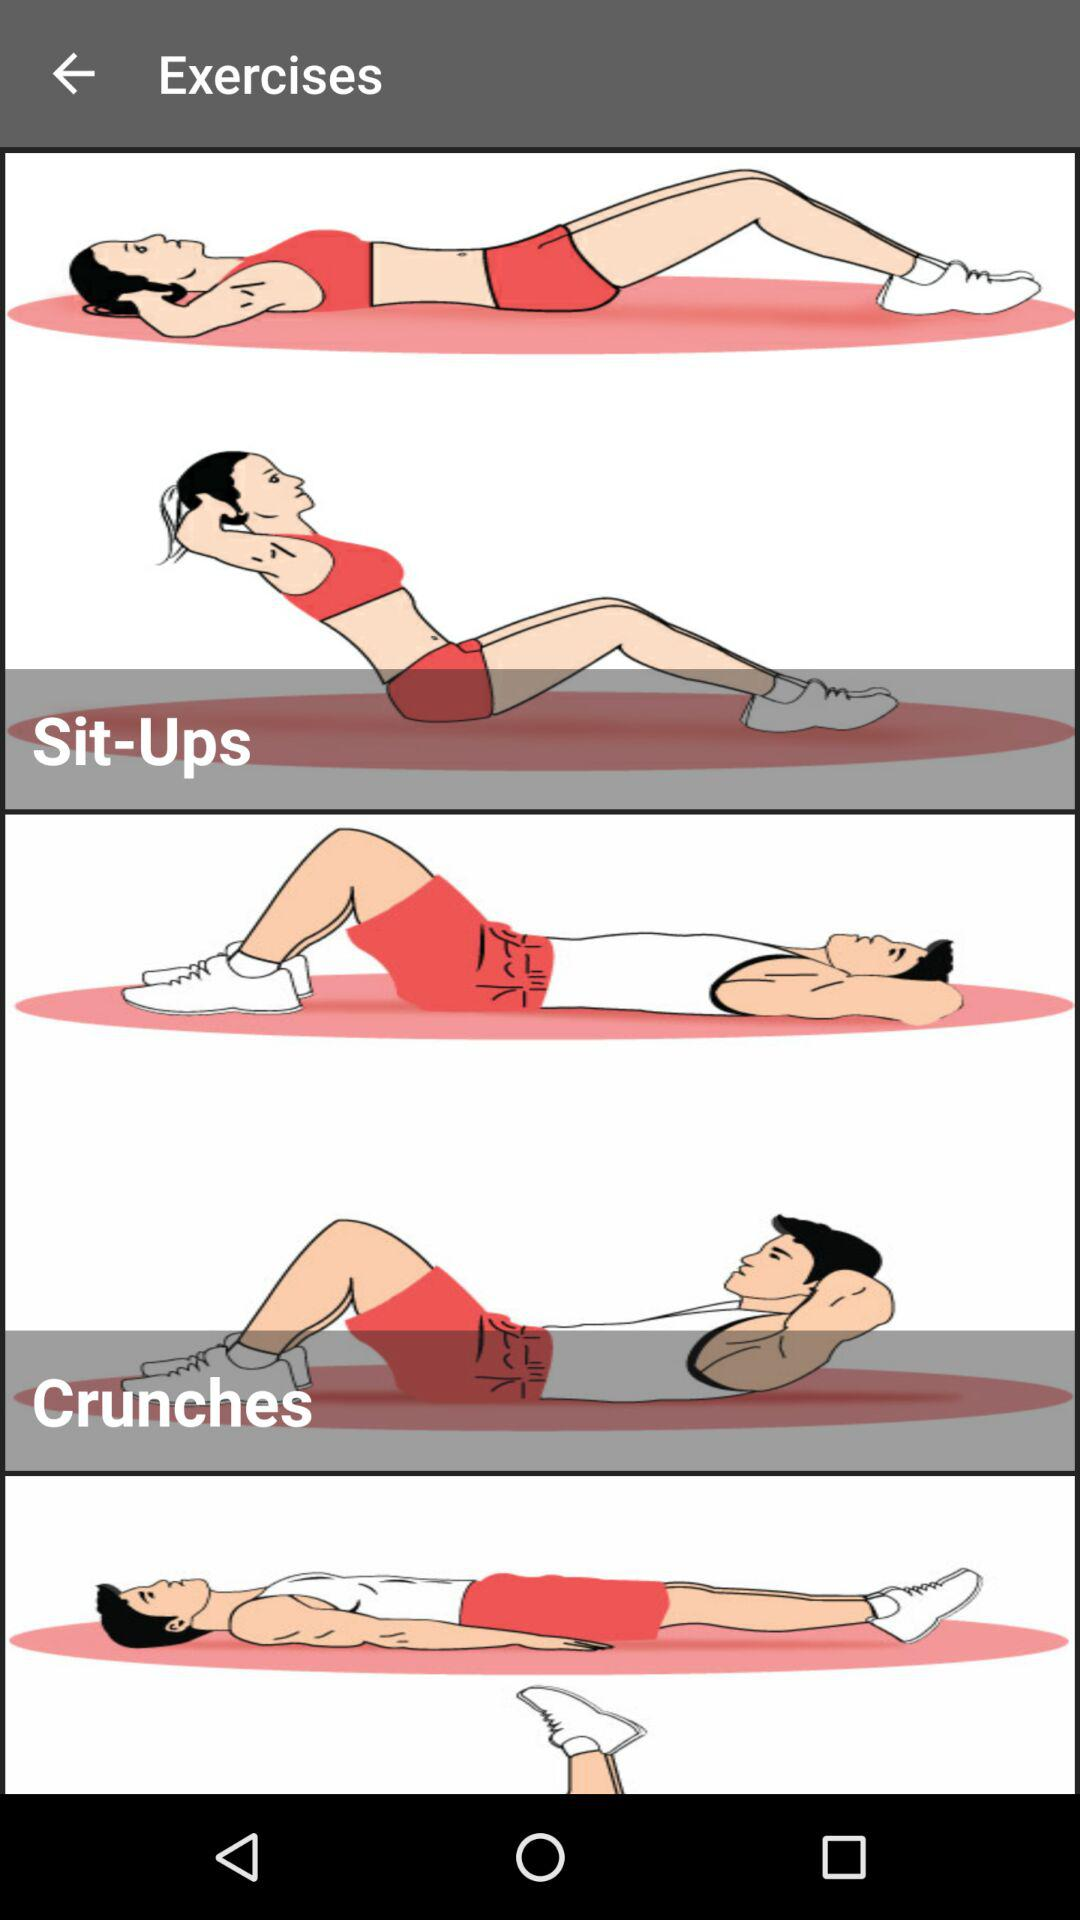Which exercise is there? The exercises are sit-ups and crunches. 